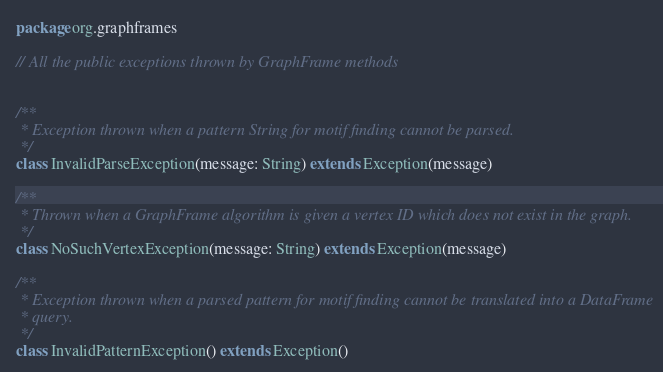<code> <loc_0><loc_0><loc_500><loc_500><_Scala_>package org.graphframes

// All the public exceptions thrown by GraphFrame methods


/**
 * Exception thrown when a pattern String for motif finding cannot be parsed.
 */
class InvalidParseException(message: String) extends Exception(message)

/**
 * Thrown when a GraphFrame algorithm is given a vertex ID which does not exist in the graph.
 */
class NoSuchVertexException(message: String) extends Exception(message)

/**
 * Exception thrown when a parsed pattern for motif finding cannot be translated into a DataFrame
 * query.
 */
class InvalidPatternException() extends Exception()</code> 